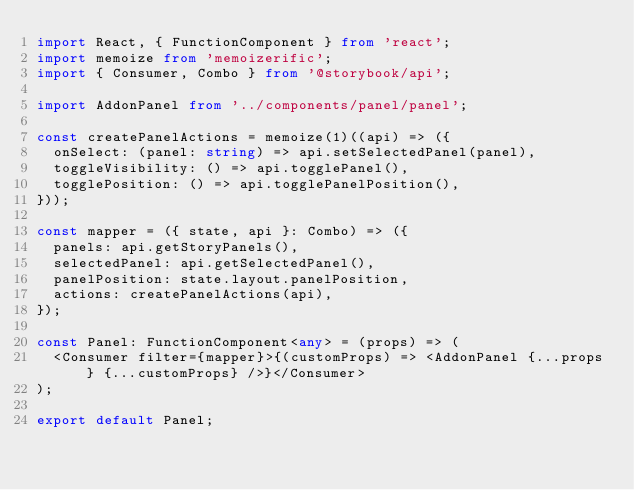Convert code to text. <code><loc_0><loc_0><loc_500><loc_500><_TypeScript_>import React, { FunctionComponent } from 'react';
import memoize from 'memoizerific';
import { Consumer, Combo } from '@storybook/api';

import AddonPanel from '../components/panel/panel';

const createPanelActions = memoize(1)((api) => ({
  onSelect: (panel: string) => api.setSelectedPanel(panel),
  toggleVisibility: () => api.togglePanel(),
  togglePosition: () => api.togglePanelPosition(),
}));

const mapper = ({ state, api }: Combo) => ({
  panels: api.getStoryPanels(),
  selectedPanel: api.getSelectedPanel(),
  panelPosition: state.layout.panelPosition,
  actions: createPanelActions(api),
});

const Panel: FunctionComponent<any> = (props) => (
  <Consumer filter={mapper}>{(customProps) => <AddonPanel {...props} {...customProps} />}</Consumer>
);

export default Panel;
</code> 